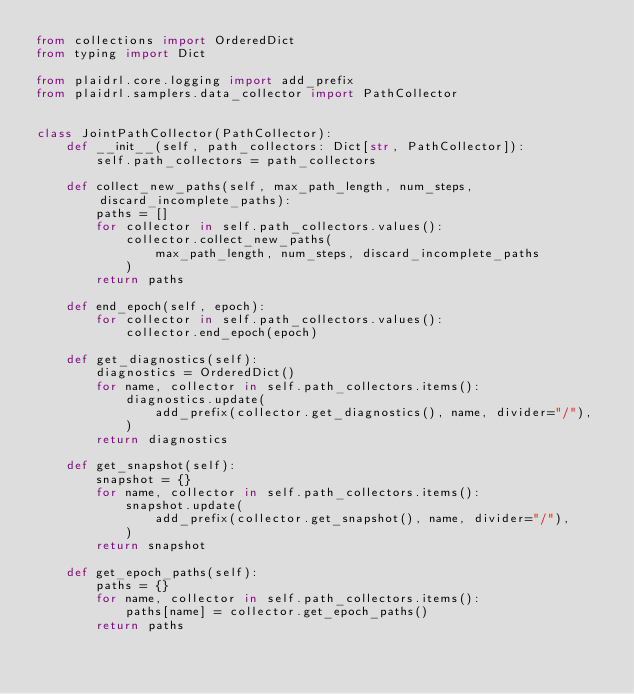<code> <loc_0><loc_0><loc_500><loc_500><_Python_>from collections import OrderedDict
from typing import Dict

from plaidrl.core.logging import add_prefix
from plaidrl.samplers.data_collector import PathCollector


class JointPathCollector(PathCollector):
    def __init__(self, path_collectors: Dict[str, PathCollector]):
        self.path_collectors = path_collectors

    def collect_new_paths(self, max_path_length, num_steps, discard_incomplete_paths):
        paths = []
        for collector in self.path_collectors.values():
            collector.collect_new_paths(
                max_path_length, num_steps, discard_incomplete_paths
            )
        return paths

    def end_epoch(self, epoch):
        for collector in self.path_collectors.values():
            collector.end_epoch(epoch)

    def get_diagnostics(self):
        diagnostics = OrderedDict()
        for name, collector in self.path_collectors.items():
            diagnostics.update(
                add_prefix(collector.get_diagnostics(), name, divider="/"),
            )
        return diagnostics

    def get_snapshot(self):
        snapshot = {}
        for name, collector in self.path_collectors.items():
            snapshot.update(
                add_prefix(collector.get_snapshot(), name, divider="/"),
            )
        return snapshot

    def get_epoch_paths(self):
        paths = {}
        for name, collector in self.path_collectors.items():
            paths[name] = collector.get_epoch_paths()
        return paths
</code> 